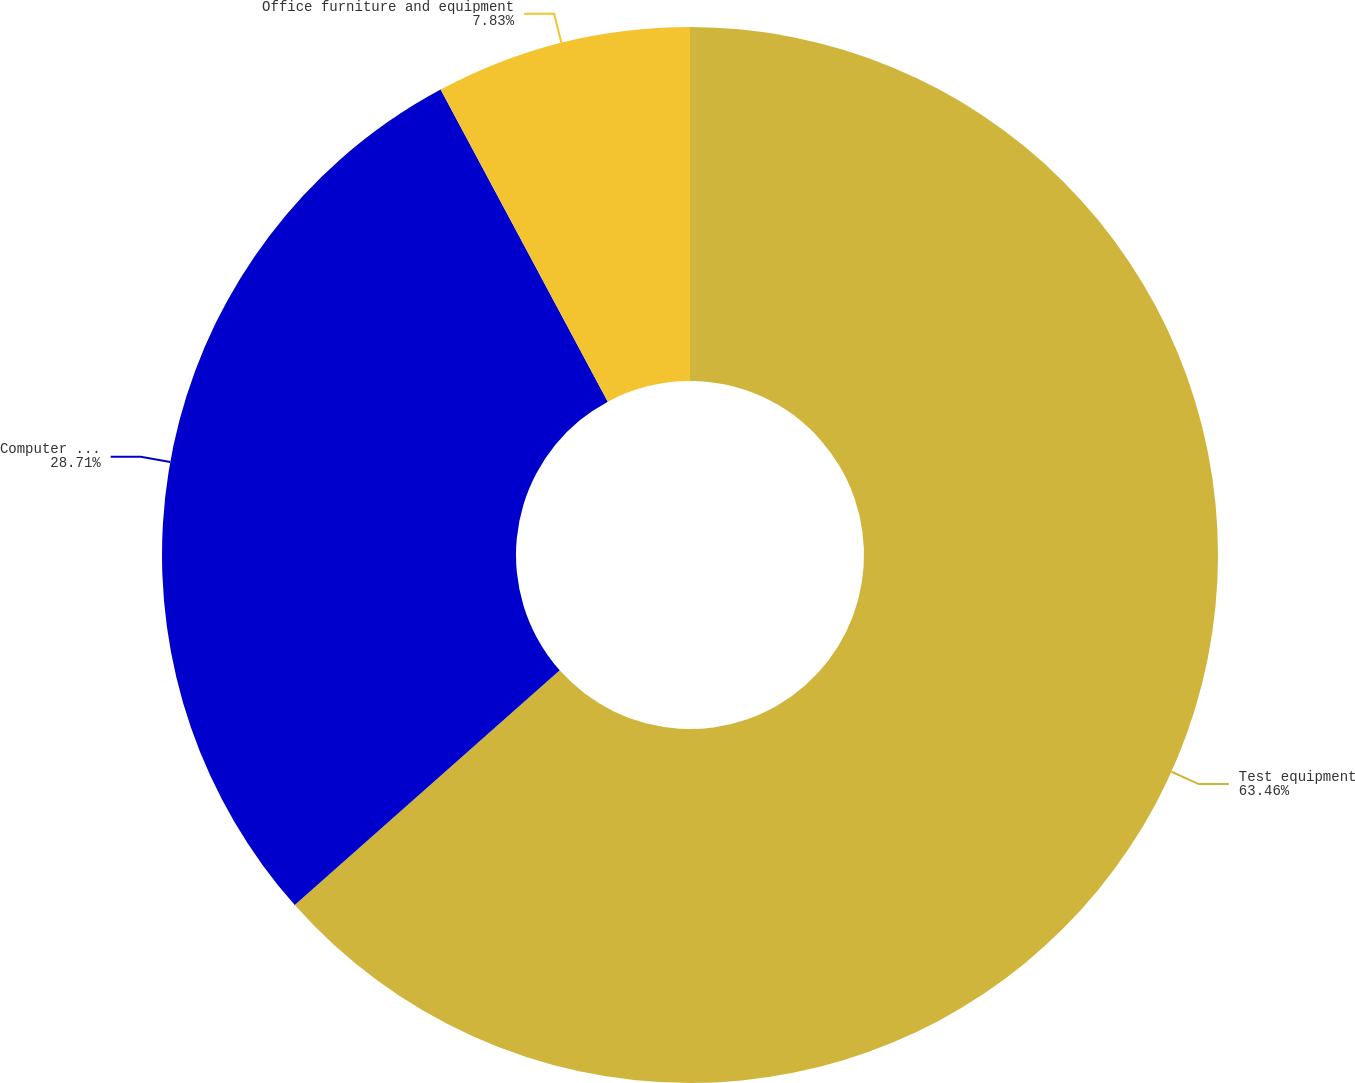Convert chart to OTSL. <chart><loc_0><loc_0><loc_500><loc_500><pie_chart><fcel>Test equipment<fcel>Computer equipment<fcel>Office furniture and equipment<nl><fcel>63.47%<fcel>28.71%<fcel>7.83%<nl></chart> 